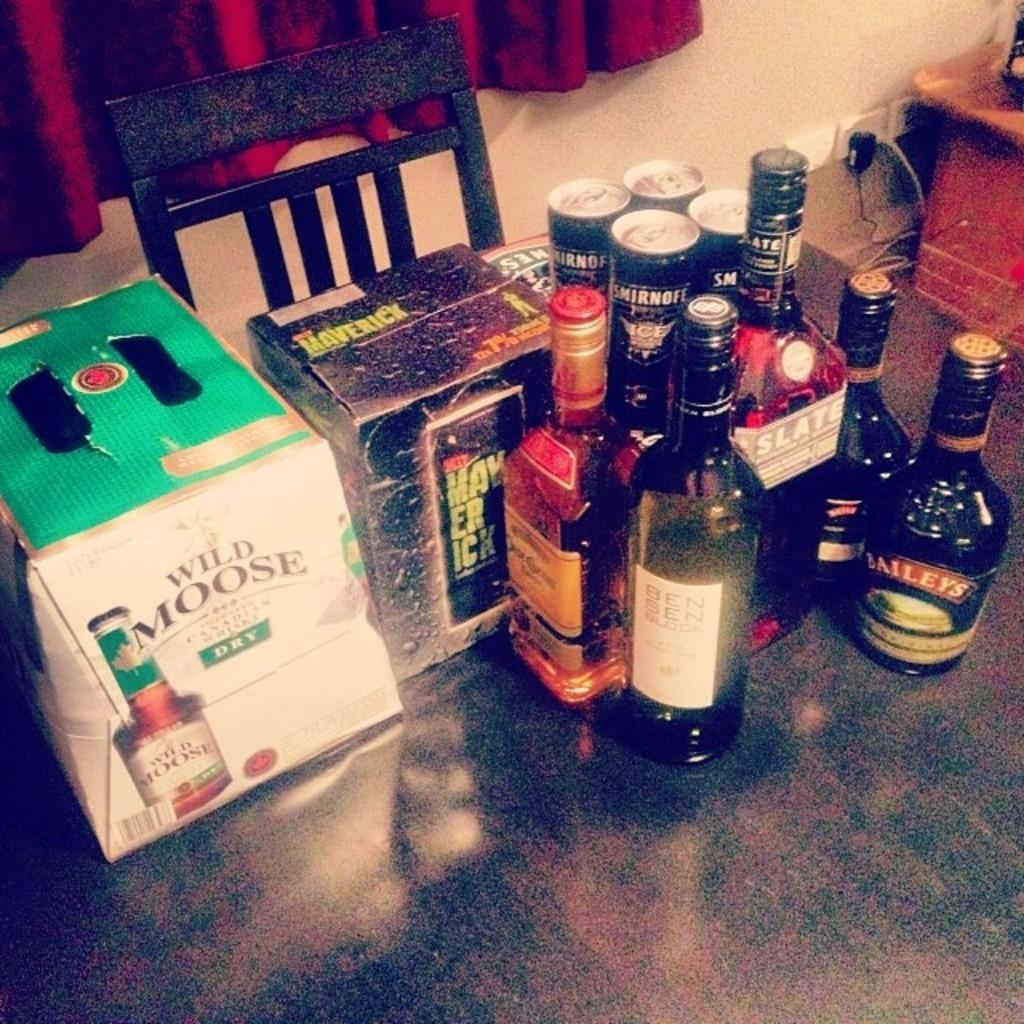<image>
Write a terse but informative summary of the picture. A row of liquor bottles are by a box of beer that says Wild Moose. 